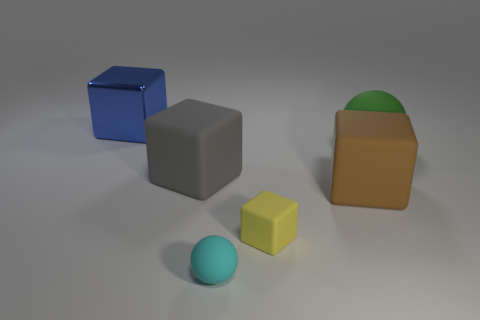Subtract all brown cubes. Subtract all cyan cylinders. How many cubes are left? 3 Add 1 brown rubber things. How many objects exist? 7 Subtract all blocks. How many objects are left? 2 Subtract 0 green cylinders. How many objects are left? 6 Subtract all large blue objects. Subtract all small rubber blocks. How many objects are left? 4 Add 4 tiny cubes. How many tiny cubes are left? 5 Add 4 metal cubes. How many metal cubes exist? 5 